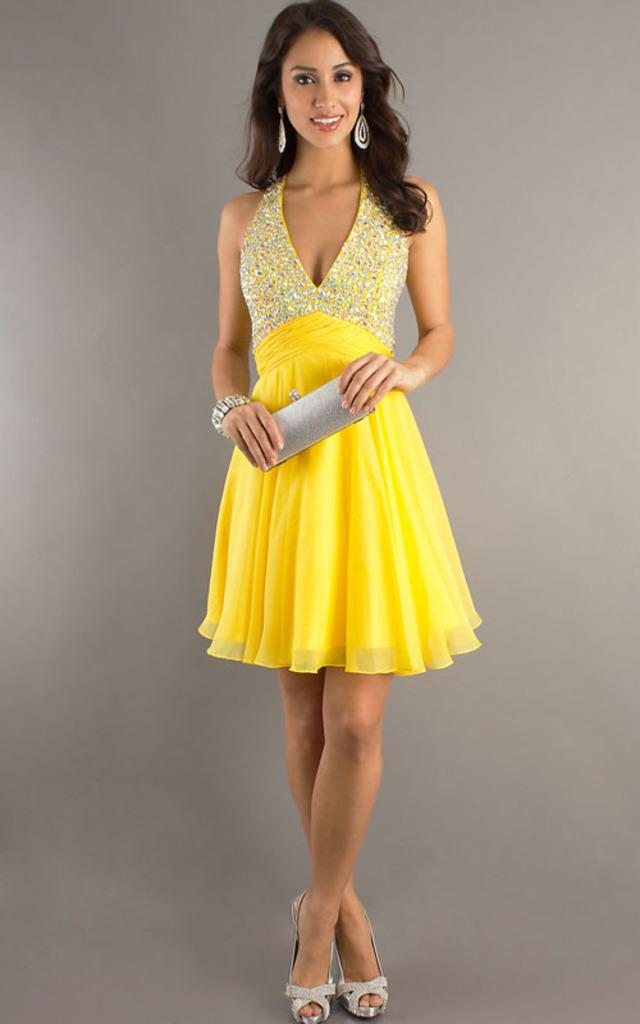Who is present in the image? There is a girl in the image. What is the girl doing in the image? The girl is smiling in the image. What object is the girl holding in her hand? The girl is holding a purse in her hand. What can be seen behind the girl in the image? There is a wall behind the girl. What type of machine is the girl operating in the image? There is no machine present in the image; the girl is simply holding a purse and smiling. 